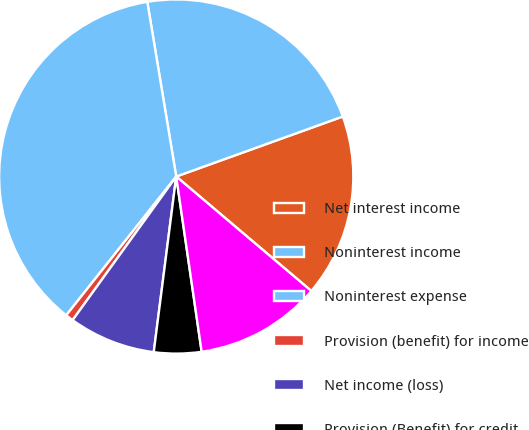<chart> <loc_0><loc_0><loc_500><loc_500><pie_chart><fcel>Net interest income<fcel>Noninterest income<fcel>Noninterest expense<fcel>Provision (benefit) for income<fcel>Net income (loss)<fcel>Provision (Benefit) for credit<fcel>Net income<nl><fcel>16.69%<fcel>22.11%<fcel>36.72%<fcel>0.72%<fcel>7.92%<fcel>4.32%<fcel>11.52%<nl></chart> 